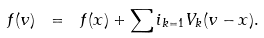Convert formula to latex. <formula><loc_0><loc_0><loc_500><loc_500>f ( v ) \ = \ f ( x ) + \sum i _ { k = 1 } V _ { k } ( v - x ) .</formula> 